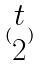<formula> <loc_0><loc_0><loc_500><loc_500>( \begin{matrix} t \\ 2 \end{matrix} )</formula> 